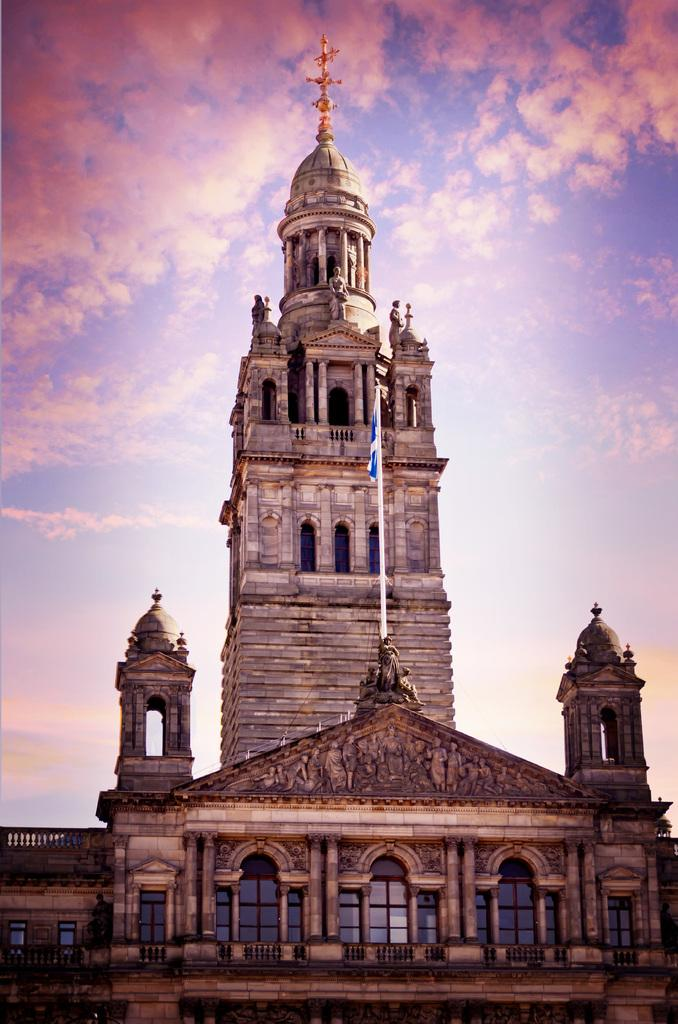What structure is present in the picture? There is a building in the picture. What is attached to the building? There is a flag on the building. What can be seen in the sky in the picture? The sky is visible at the top of the picture, and it is clear. What type of toothpaste is being advertised on the building in the image? There is no toothpaste being advertised on the building in the image. What is your opinion on the design of the flag in the image? The question asks for an opinion, which is not based on the facts provided. Instead, we can focus on the facts: the flag is on the building. --- Facts: 1. There is a car in the picture. 2. The car is red. 3. The car has four wheels. 4. There is a road in the picture. 5. The road is paved. Absurd Topics: elephant, ocean, book Conversation: What vehicle is present in the picture? There is a car in the picture. What color is the car? The car is red. How many wheels does the car have? The car has four wheels. What type of surface is the car on? There is a road in the picture, and it is paved. Reasoning: Let's think step by step in order to produce the conversation. We start by identifying the main subject in the image, which is the car. Then, we expand the conversation to include other details about the car, such as its color and the number of wheels. Finally, we describe the road's condition, which is paved, to give a sense of the environment. Absurd Question/Answer: Can you see an elephant swimming in the ocean in the image? There is no elephant or ocean present in the image. What book is the car reading in the image? Cars do not read books, and there is no book present in the image. 